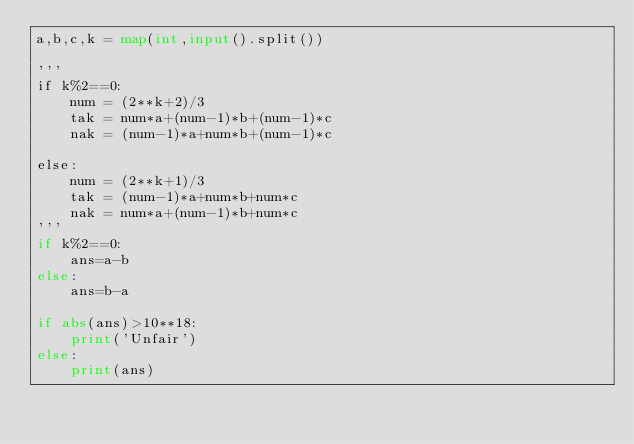<code> <loc_0><loc_0><loc_500><loc_500><_Python_>a,b,c,k = map(int,input().split())

'''
if k%2==0:
    num = (2**k+2)/3
    tak = num*a+(num-1)*b+(num-1)*c
    nak = (num-1)*a+num*b+(num-1)*c

else:
    num = (2**k+1)/3
    tak = (num-1)*a+num*b+num*c
    nak = num*a+(num-1)*b+num*c
'''
if k%2==0:
    ans=a-b
else:
    ans=b-a

if abs(ans)>10**18:
    print('Unfair')
else:
    print(ans)

</code> 